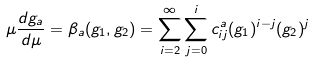<formula> <loc_0><loc_0><loc_500><loc_500>\mu \frac { d g _ { a } } { d \mu } = \beta _ { a } ( g _ { 1 } , g _ { 2 } ) = \sum _ { i = 2 } ^ { \infty } \sum _ { j = 0 } ^ { i } c _ { i j } ^ { a } ( g _ { 1 } ) ^ { i - j } ( g _ { 2 } ) ^ { j }</formula> 